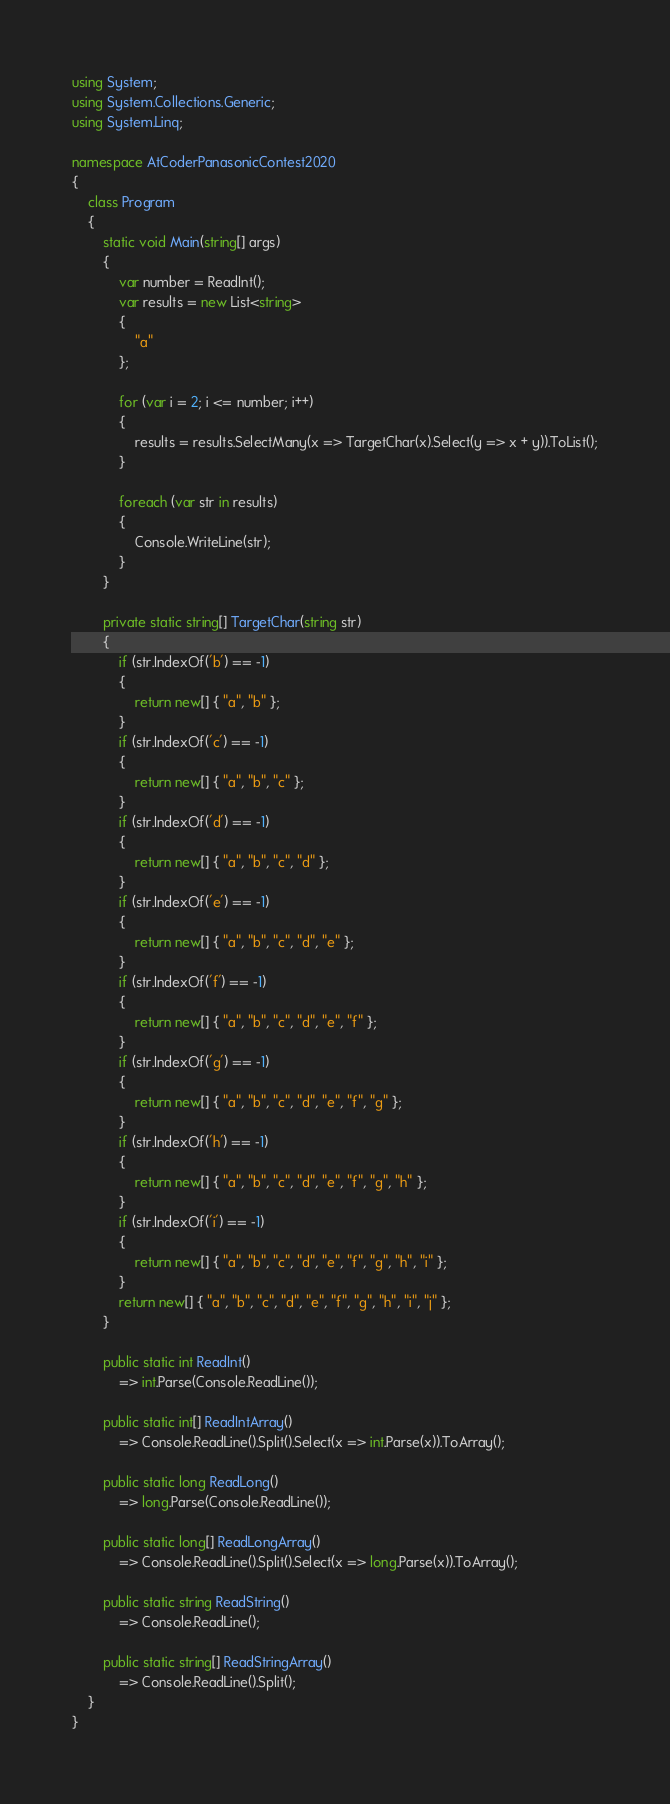<code> <loc_0><loc_0><loc_500><loc_500><_C#_>using System;
using System.Collections.Generic;
using System.Linq;

namespace AtCoderPanasonicContest2020
{
	class Program
	{
		static void Main(string[] args)
		{
			var number = ReadInt();
			var results = new List<string>
			{
				"a"
			};

			for (var i = 2; i <= number; i++)
			{
				results = results.SelectMany(x => TargetChar(x).Select(y => x + y)).ToList();
			}

			foreach (var str in results)
			{
				Console.WriteLine(str);
			}
		}

		private static string[] TargetChar(string str)
		{
			if (str.IndexOf('b') == -1)
			{
				return new[] { "a", "b" };
			}
			if (str.IndexOf('c') == -1)
			{
				return new[] { "a", "b", "c" };
			}
			if (str.IndexOf('d') == -1)
			{
				return new[] { "a", "b", "c", "d" };
			}
			if (str.IndexOf('e') == -1)
			{
				return new[] { "a", "b", "c", "d", "e" };
			}
			if (str.IndexOf('f') == -1)
			{
				return new[] { "a", "b", "c", "d", "e", "f" };
			}
			if (str.IndexOf('g') == -1)
			{
				return new[] { "a", "b", "c", "d", "e", "f", "g" };
			}
			if (str.IndexOf('h') == -1)
			{
				return new[] { "a", "b", "c", "d", "e", "f", "g", "h" };
			}
			if (str.IndexOf('i') == -1)
			{
				return new[] { "a", "b", "c", "d", "e", "f", "g", "h", "i" };
			}
			return new[] { "a", "b", "c", "d", "e", "f", "g", "h", "i", "j" };
		}

		public static int ReadInt()
			=> int.Parse(Console.ReadLine());

		public static int[] ReadIntArray()
			=> Console.ReadLine().Split().Select(x => int.Parse(x)).ToArray();

		public static long ReadLong()
			=> long.Parse(Console.ReadLine());

		public static long[] ReadLongArray()
			=> Console.ReadLine().Split().Select(x => long.Parse(x)).ToArray();

		public static string ReadString()
			=> Console.ReadLine();

		public static string[] ReadStringArray()
			=> Console.ReadLine().Split();
	}
}
</code> 